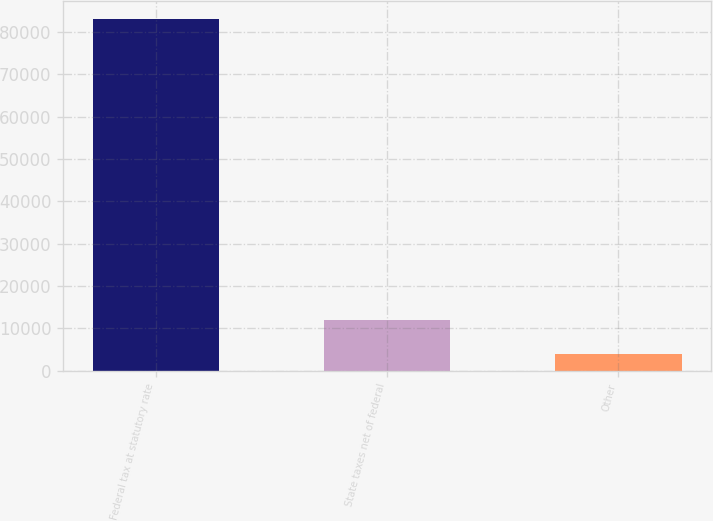<chart> <loc_0><loc_0><loc_500><loc_500><bar_chart><fcel>Federal tax at statutory rate<fcel>State taxes net of federal<fcel>Other<nl><fcel>83032<fcel>11880.7<fcel>3975<nl></chart> 